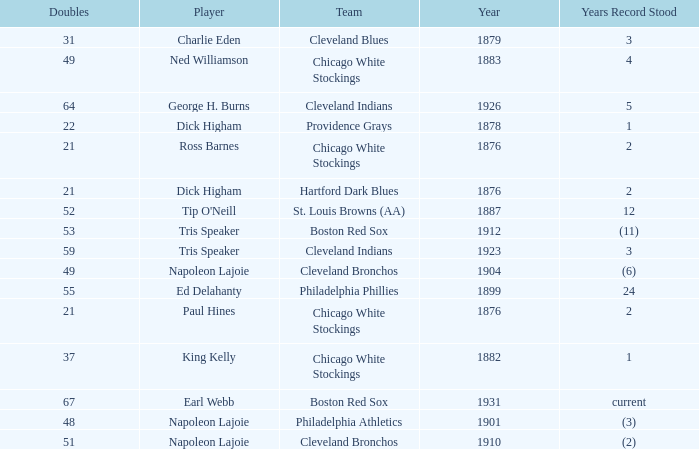Player of napoleon lajoie, and a Team of cleveland bronchos, and a Doubles of 49 which years record stood? (6). 